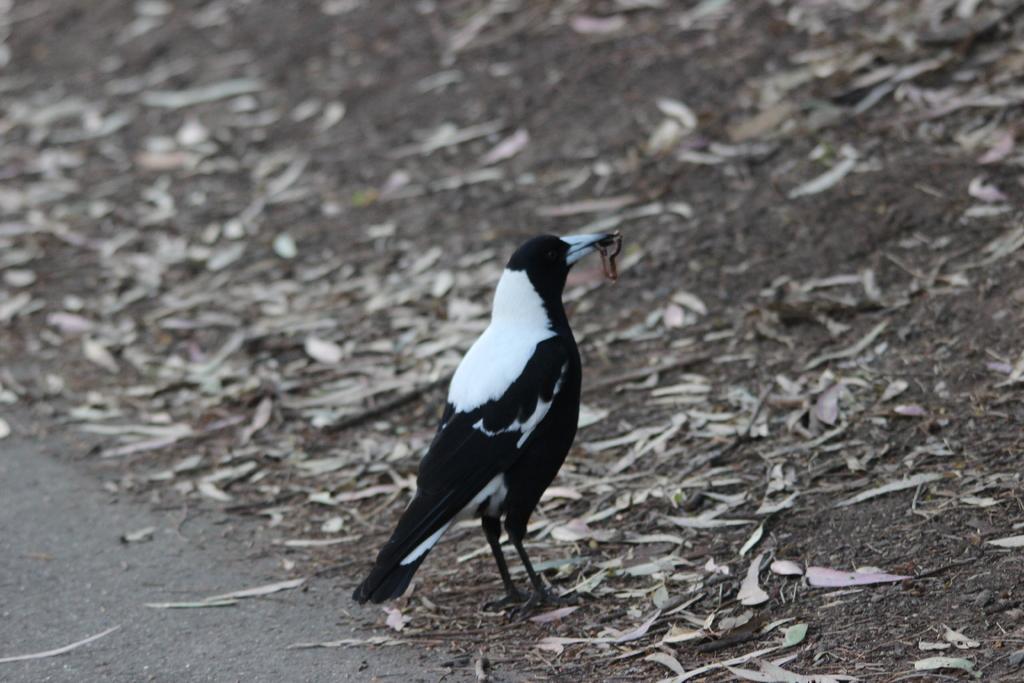How would you summarize this image in a sentence or two? In this picture we can see a bird which is in black, white color. We can see the dried leaves on the ground. It seems like a bird is holding an insect with its beak. 